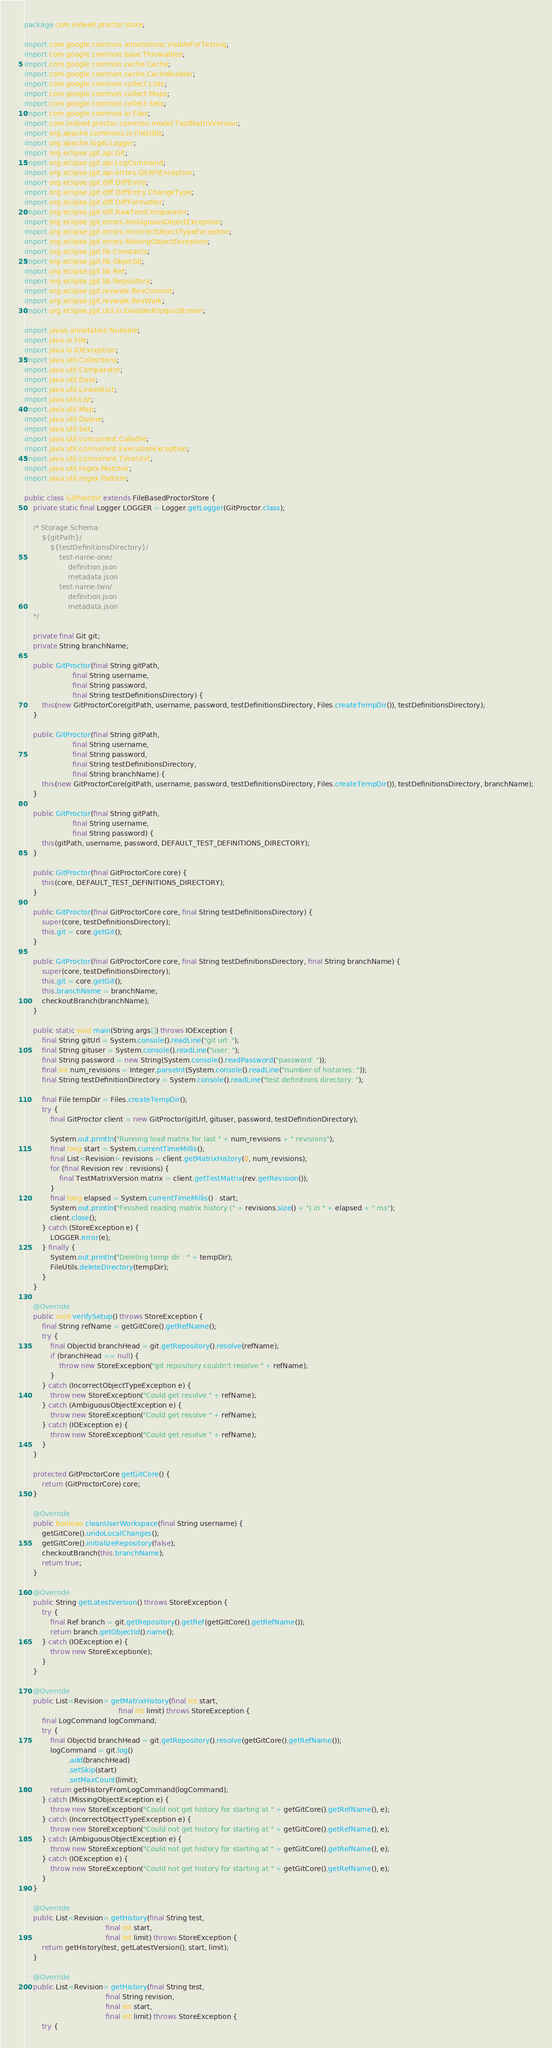<code> <loc_0><loc_0><loc_500><loc_500><_Java_>package com.indeed.proctor.store;

import com.google.common.annotations.VisibleForTesting;
import com.google.common.base.Throwables;
import com.google.common.cache.Cache;
import com.google.common.cache.CacheBuilder;
import com.google.common.collect.Lists;
import com.google.common.collect.Maps;
import com.google.common.collect.Sets;
import com.google.common.io.Files;
import com.indeed.proctor.common.model.TestMatrixVersion;
import org.apache.commons.io.FileUtils;
import org.apache.log4j.Logger;
import org.eclipse.jgit.api.Git;
import org.eclipse.jgit.api.LogCommand;
import org.eclipse.jgit.api.errors.GitAPIException;
import org.eclipse.jgit.diff.DiffEntry;
import org.eclipse.jgit.diff.DiffEntry.ChangeType;
import org.eclipse.jgit.diff.DiffFormatter;
import org.eclipse.jgit.diff.RawTextComparator;
import org.eclipse.jgit.errors.AmbiguousObjectException;
import org.eclipse.jgit.errors.IncorrectObjectTypeException;
import org.eclipse.jgit.errors.MissingObjectException;
import org.eclipse.jgit.lib.Constants;
import org.eclipse.jgit.lib.ObjectId;
import org.eclipse.jgit.lib.Ref;
import org.eclipse.jgit.lib.Repository;
import org.eclipse.jgit.revwalk.RevCommit;
import org.eclipse.jgit.revwalk.RevWalk;
import org.eclipse.jgit.util.io.DisabledOutputStream;

import javax.annotation.Nullable;
import java.io.File;
import java.io.IOException;
import java.util.Collections;
import java.util.Comparator;
import java.util.Date;
import java.util.LinkedList;
import java.util.List;
import java.util.Map;
import java.util.Queue;
import java.util.Set;
import java.util.concurrent.Callable;
import java.util.concurrent.ExecutionException;
import java.util.concurrent.TimeUnit;
import java.util.regex.Matcher;
import java.util.regex.Pattern;

public class GitProctor extends FileBasedProctorStore {
    private static final Logger LOGGER = Logger.getLogger(GitProctor.class);

    /* Storage Schema:
        ${gitPath}/
            ${testDefinitionsDirectory}/
                test-name-one/
                    definition.json
                    metadata.json
                test-name-two/
                    definition.json
                    metadata.json
    */

    private final Git git;
    private String branchName;

    public GitProctor(final String gitPath,
                      final String username,
                      final String password,
                      final String testDefinitionsDirectory) {
        this(new GitProctorCore(gitPath, username, password, testDefinitionsDirectory, Files.createTempDir()), testDefinitionsDirectory);
    }

    public GitProctor(final String gitPath,
                      final String username,
                      final String password,
                      final String testDefinitionsDirectory,
                      final String branchName) {
        this(new GitProctorCore(gitPath, username, password, testDefinitionsDirectory, Files.createTempDir()), testDefinitionsDirectory, branchName);
    }

    public GitProctor(final String gitPath,
                      final String username,
                      final String password) {
        this(gitPath, username, password, DEFAULT_TEST_DEFINITIONS_DIRECTORY);
    }

    public GitProctor(final GitProctorCore core) {
        this(core, DEFAULT_TEST_DEFINITIONS_DIRECTORY);
    }

    public GitProctor(final GitProctorCore core, final String testDefinitionsDirectory) {
        super(core, testDefinitionsDirectory);
        this.git = core.getGit();
    }

    public GitProctor(final GitProctorCore core, final String testDefinitionsDirectory, final String branchName) {
        super(core, testDefinitionsDirectory);
        this.git = core.getGit();
        this.branchName = branchName;
        checkoutBranch(branchName);
    }

    public static void main(String args[]) throws IOException {
        final String gitUrl = System.console().readLine("git url: ");
        final String gituser = System.console().readLine("user: ");
        final String password = new String(System.console().readPassword("password: "));
        final int num_revisions = Integer.parseInt(System.console().readLine("number of histories: "));
        final String testDefinitionDirectory = System.console().readLine("test definitions directory: ");

        final File tempDir = Files.createTempDir();
        try {
            final GitProctor client = new GitProctor(gitUrl, gituser, password, testDefinitionDirectory);

            System.out.println("Running load matrix for last " + num_revisions + " revisions");
            final long start = System.currentTimeMillis();
            final List<Revision> revisions = client.getMatrixHistory(0, num_revisions);
            for (final Revision rev : revisions) {
                final TestMatrixVersion matrix = client.getTestMatrix(rev.getRevision());
            }
            final long elapsed = System.currentTimeMillis() - start;
            System.out.println("Finished reading matrix history (" + revisions.size() + ") in " + elapsed + " ms");
            client.close();
        } catch (StoreException e) {
            LOGGER.error(e);
        } finally {
            System.out.println("Deleting temp dir : " + tempDir);
            FileUtils.deleteDirectory(tempDir);
        }
    }

    @Override
    public void verifySetup() throws StoreException {
        final String refName = getGitCore().getRefName();
        try {
            final ObjectId branchHead = git.getRepository().resolve(refName);
            if (branchHead == null) {
                throw new StoreException("git repository couldn't resolve " + refName);
            }
        } catch (IncorrectObjectTypeException e) {
            throw new StoreException("Could get resolve " + refName);
        } catch (AmbiguousObjectException e) {
            throw new StoreException("Could get resolve " + refName);
        } catch (IOException e) {
            throw new StoreException("Could get resolve " + refName);
        }
    }

    protected GitProctorCore getGitCore() {
        return (GitProctorCore) core;
    }

    @Override
    public boolean cleanUserWorkspace(final String username) {
        getGitCore().undoLocalChanges();
        getGitCore().initializeRepository(false);
        checkoutBranch(this.branchName);
        return true;
    }

    @Override
    public String getLatestVersion() throws StoreException {
        try {
            final Ref branch = git.getRepository().getRef(getGitCore().getRefName());
            return branch.getObjectId().name();
        } catch (IOException e) {
            throw new StoreException(e);
        }
    }

    @Override
    public List<Revision> getMatrixHistory(final int start,
                                           final int limit) throws StoreException {
        final LogCommand logCommand;
        try {
            final ObjectId branchHead = git.getRepository().resolve(getGitCore().getRefName());
            logCommand = git.log()
                    .add(branchHead)
                    .setSkip(start)
                    .setMaxCount(limit);
            return getHistoryFromLogCommand(logCommand);
        } catch (MissingObjectException e) {
            throw new StoreException("Could not get history for starting at " + getGitCore().getRefName(), e);
        } catch (IncorrectObjectTypeException e) {
            throw new StoreException("Could not get history for starting at " + getGitCore().getRefName(), e);
        } catch (AmbiguousObjectException e) {
            throw new StoreException("Could not get history for starting at " + getGitCore().getRefName(), e);
        } catch (IOException e) {
            throw new StoreException("Could not get history for starting at " + getGitCore().getRefName(), e);
        }
    }

    @Override
    public List<Revision> getHistory(final String test,
                                     final int start,
                                     final int limit) throws StoreException {
        return getHistory(test, getLatestVersion(), start, limit);
    }

    @Override
    public List<Revision> getHistory(final String test,
                                     final String revision,
                                     final int start,
                                     final int limit) throws StoreException {
        try {</code> 